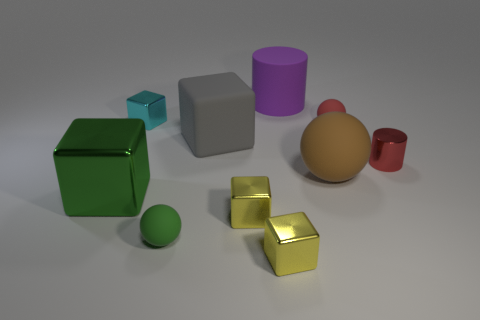There is a yellow cube behind the green ball; is there a small rubber object that is to the right of it?
Ensure brevity in your answer.  Yes. Are there any purple matte things that have the same size as the green block?
Provide a short and direct response. Yes. There is a tiny metal object that is in front of the tiny green sphere; does it have the same color as the large matte ball?
Your answer should be very brief. No. The matte cube is what size?
Ensure brevity in your answer.  Large. There is a matte sphere in front of the large object that is in front of the large brown thing; how big is it?
Provide a succinct answer. Small. How many big shiny things have the same color as the small metallic cylinder?
Your answer should be very brief. 0. How many small shiny cylinders are there?
Give a very brief answer. 1. What number of green objects are the same material as the small red ball?
Provide a short and direct response. 1. There is a red object that is the same shape as the purple rubber thing; what size is it?
Give a very brief answer. Small. What material is the purple cylinder?
Your answer should be very brief. Rubber. 